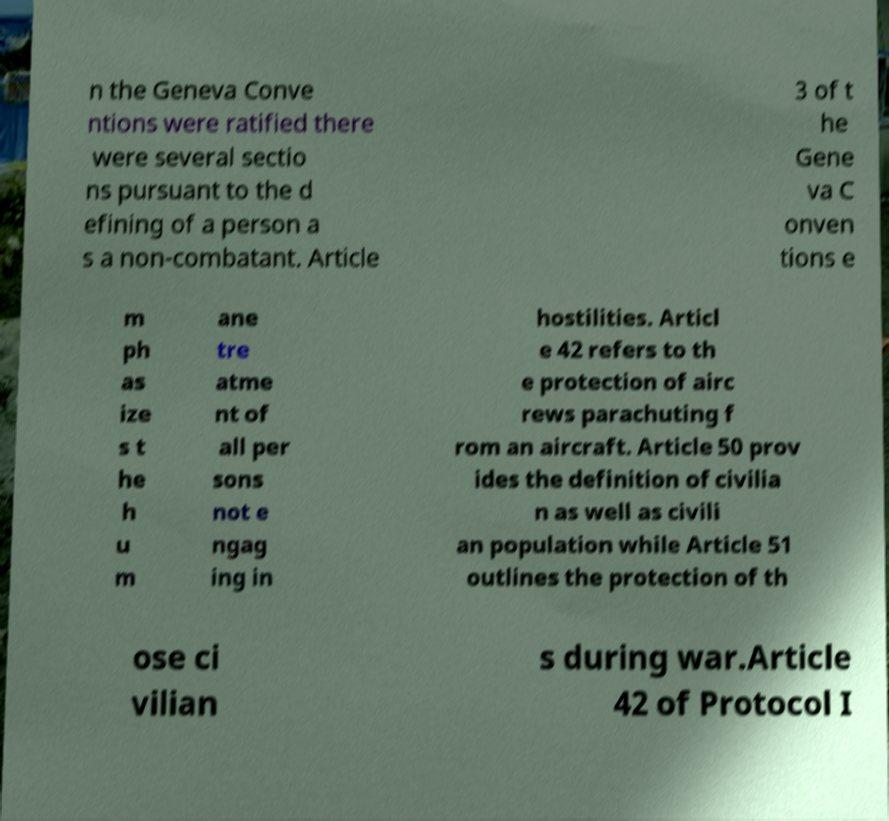Can you accurately transcribe the text from the provided image for me? n the Geneva Conve ntions were ratified there were several sectio ns pursuant to the d efining of a person a s a non-combatant. Article 3 of t he Gene va C onven tions e m ph as ize s t he h u m ane tre atme nt of all per sons not e ngag ing in hostilities. Articl e 42 refers to th e protection of airc rews parachuting f rom an aircraft. Article 50 prov ides the definition of civilia n as well as civili an population while Article 51 outlines the protection of th ose ci vilian s during war.Article 42 of Protocol I 